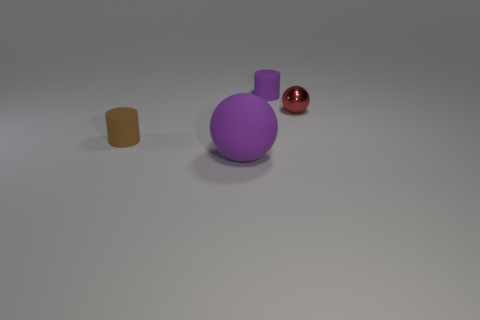Is there any other thing that has the same material as the small ball?
Give a very brief answer. No. Do the red shiny ball and the brown matte object have the same size?
Keep it short and to the point. Yes. There is a ball that is the same material as the tiny purple thing; what size is it?
Offer a very short reply. Large. How many cylinders are the same color as the big object?
Offer a very short reply. 1. Is the number of tiny matte things right of the tiny purple thing less than the number of cylinders that are left of the big purple thing?
Keep it short and to the point. Yes. There is a purple object to the left of the purple rubber cylinder; is its shape the same as the red shiny object?
Your response must be concise. Yes. Does the tiny cylinder behind the brown thing have the same material as the big purple sphere?
Your answer should be compact. Yes. There is a cylinder behind the small matte thing in front of the purple rubber thing that is behind the large rubber sphere; what is its material?
Offer a very short reply. Rubber. How many other objects are there of the same shape as the tiny red thing?
Provide a succinct answer. 1. What color is the matte thing that is behind the small metal thing?
Ensure brevity in your answer.  Purple. 